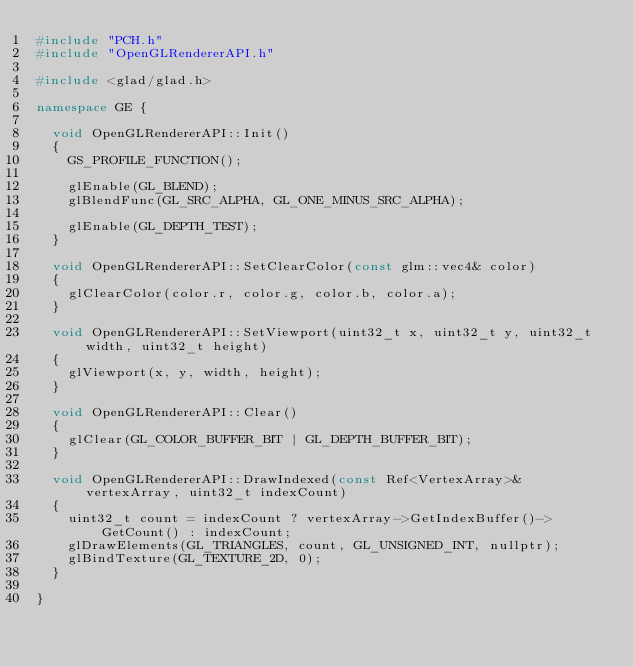<code> <loc_0><loc_0><loc_500><loc_500><_C++_>#include "PCH.h"
#include "OpenGLRendererAPI.h"

#include <glad/glad.h>

namespace GE {

	void OpenGLRendererAPI::Init()
	{
		GS_PROFILE_FUNCTION();

		glEnable(GL_BLEND);
		glBlendFunc(GL_SRC_ALPHA, GL_ONE_MINUS_SRC_ALPHA);

		glEnable(GL_DEPTH_TEST);
	}

	void OpenGLRendererAPI::SetClearColor(const glm::vec4& color)
	{
		glClearColor(color.r, color.g, color.b, color.a);
	}

	void OpenGLRendererAPI::SetViewport(uint32_t x, uint32_t y, uint32_t width, uint32_t height)
	{
		glViewport(x, y, width, height);
	}

	void OpenGLRendererAPI::Clear()
	{
		glClear(GL_COLOR_BUFFER_BIT | GL_DEPTH_BUFFER_BIT);
	}

	void OpenGLRendererAPI::DrawIndexed(const Ref<VertexArray>& vertexArray, uint32_t indexCount)
	{
		uint32_t count = indexCount ? vertexArray->GetIndexBuffer()->GetCount() : indexCount;
		glDrawElements(GL_TRIANGLES, count, GL_UNSIGNED_INT, nullptr);
		glBindTexture(GL_TEXTURE_2D, 0);
	}

}</code> 